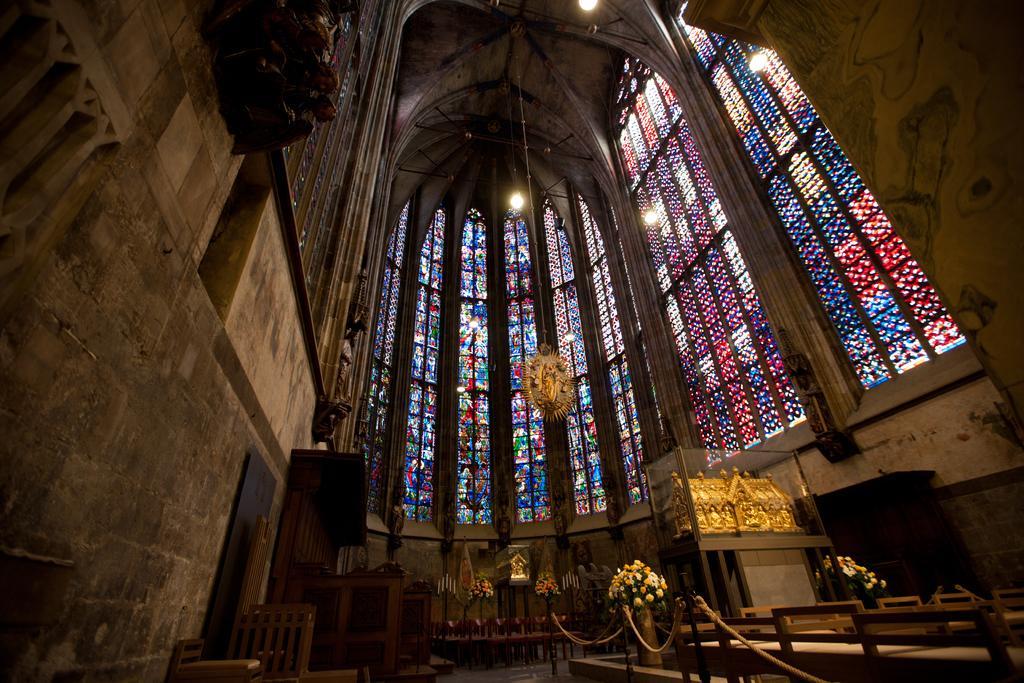Please provide a concise description of this image. This picture is taken inside the building. In this image, on the right side, we can see a glass box, in the glass box, we can see some object in it. On the right side, we can see some tables, chairs and rope, flower pot, plant, flowers. On the left side, we can also see a wall, chairs. In the background, we can also see some flowers, wood object. In the background, we can see a glass window. At the top, we can see a roof with few lights. 